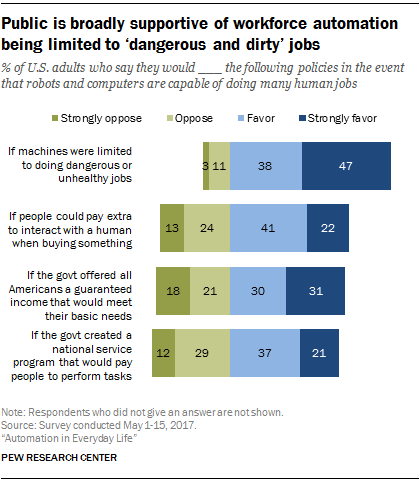Indicate a few pertinent items in this graphic. The color of the leftmost bar is green. The median of all dark blue bar values is 0.265. 